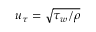Convert formula to latex. <formula><loc_0><loc_0><loc_500><loc_500>u _ { \tau } = \sqrt { \tau _ { w } / \rho }</formula> 